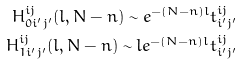Convert formula to latex. <formula><loc_0><loc_0><loc_500><loc_500>H ^ { i j } _ { 0 i ^ { \prime } j ^ { \prime } } ( l , N - n ) \sim e ^ { - ( N - n ) l } t ^ { i j } _ { i ^ { \prime } j ^ { \prime } } \\ H ^ { i j } _ { 1 i ^ { \prime } j ^ { \prime } } ( l , N - n ) \sim l e ^ { - ( N - n ) l } t ^ { i j } _ { i ^ { \prime } j ^ { \prime } }</formula> 